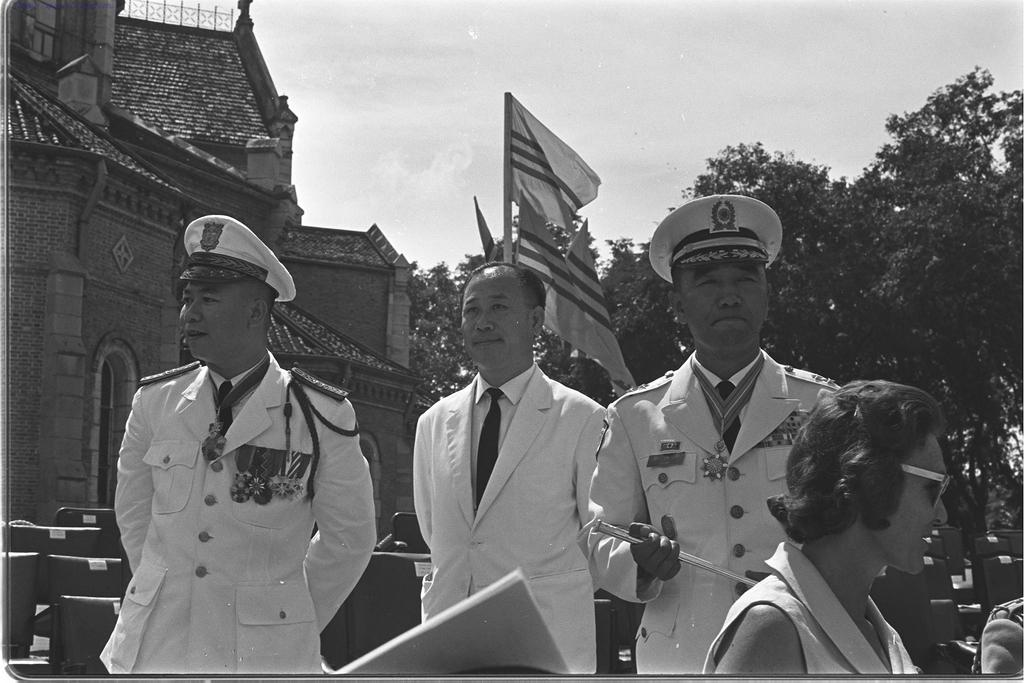What are the persons in the image doing? The persons in the image are standing and holding a stick. What can be seen in the background of the image? There are chairs, trees, flags, a building, and the sky visible in the background of the image. What type of wound can be seen on the daughter's arm in the image? There is no daughter present in the image, and therefore no wound can be observed. 